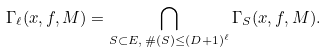<formula> <loc_0><loc_0><loc_500><loc_500>\Gamma _ { \ell } ( x , f , M ) = \bigcap _ { S \subset E , \, \# ( S ) \leq ( D + 1 ) ^ { \ell } } \Gamma _ { S } ( x , f , M ) .</formula> 